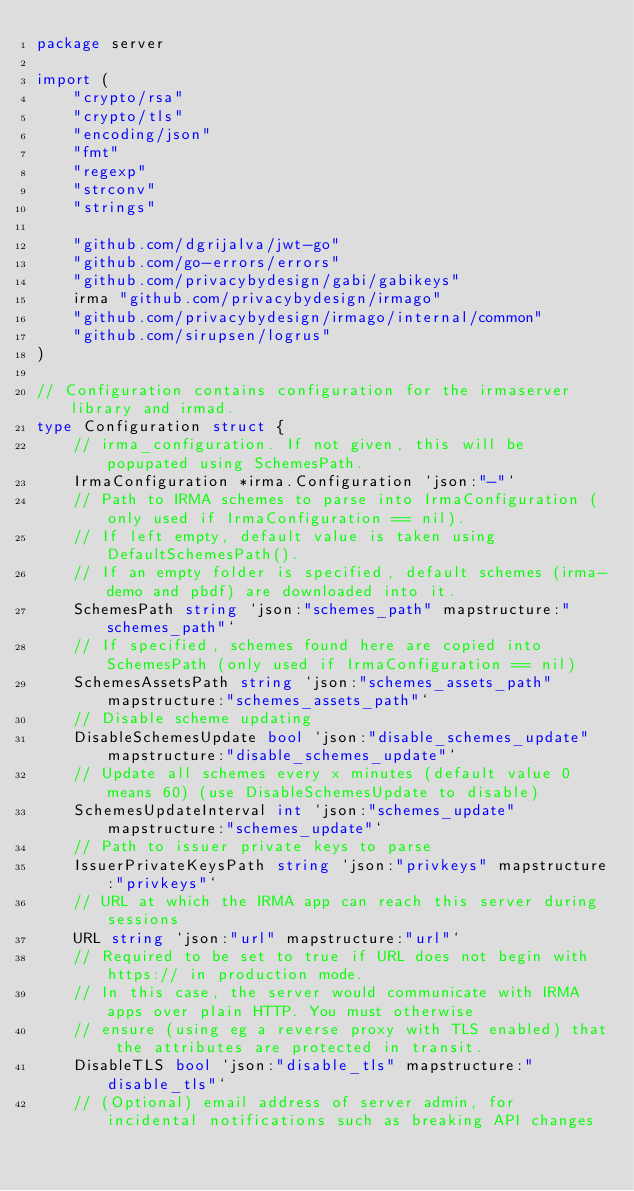<code> <loc_0><loc_0><loc_500><loc_500><_Go_>package server

import (
	"crypto/rsa"
	"crypto/tls"
	"encoding/json"
	"fmt"
	"regexp"
	"strconv"
	"strings"

	"github.com/dgrijalva/jwt-go"
	"github.com/go-errors/errors"
	"github.com/privacybydesign/gabi/gabikeys"
	irma "github.com/privacybydesign/irmago"
	"github.com/privacybydesign/irmago/internal/common"
	"github.com/sirupsen/logrus"
)

// Configuration contains configuration for the irmaserver library and irmad.
type Configuration struct {
	// irma_configuration. If not given, this will be popupated using SchemesPath.
	IrmaConfiguration *irma.Configuration `json:"-"`
	// Path to IRMA schemes to parse into IrmaConfiguration (only used if IrmaConfiguration == nil).
	// If left empty, default value is taken using DefaultSchemesPath().
	// If an empty folder is specified, default schemes (irma-demo and pbdf) are downloaded into it.
	SchemesPath string `json:"schemes_path" mapstructure:"schemes_path"`
	// If specified, schemes found here are copied into SchemesPath (only used if IrmaConfiguration == nil)
	SchemesAssetsPath string `json:"schemes_assets_path" mapstructure:"schemes_assets_path"`
	// Disable scheme updating
	DisableSchemesUpdate bool `json:"disable_schemes_update" mapstructure:"disable_schemes_update"`
	// Update all schemes every x minutes (default value 0 means 60) (use DisableSchemesUpdate to disable)
	SchemesUpdateInterval int `json:"schemes_update" mapstructure:"schemes_update"`
	// Path to issuer private keys to parse
	IssuerPrivateKeysPath string `json:"privkeys" mapstructure:"privkeys"`
	// URL at which the IRMA app can reach this server during sessions
	URL string `json:"url" mapstructure:"url"`
	// Required to be set to true if URL does not begin with https:// in production mode.
	// In this case, the server would communicate with IRMA apps over plain HTTP. You must otherwise
	// ensure (using eg a reverse proxy with TLS enabled) that the attributes are protected in transit.
	DisableTLS bool `json:"disable_tls" mapstructure:"disable_tls"`
	// (Optional) email address of server admin, for incidental notifications such as breaking API changes</code> 